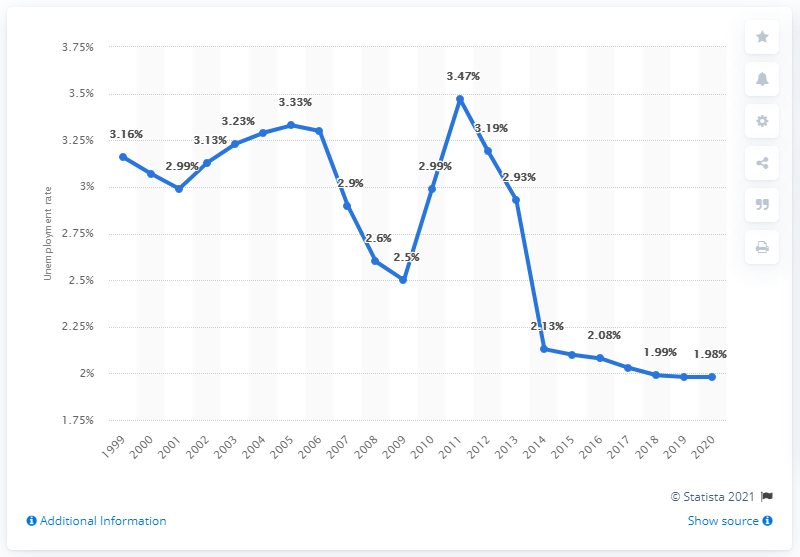Specify some key components in this picture. The unemployment rate in Tanzania in 2020 was 1.98%. 